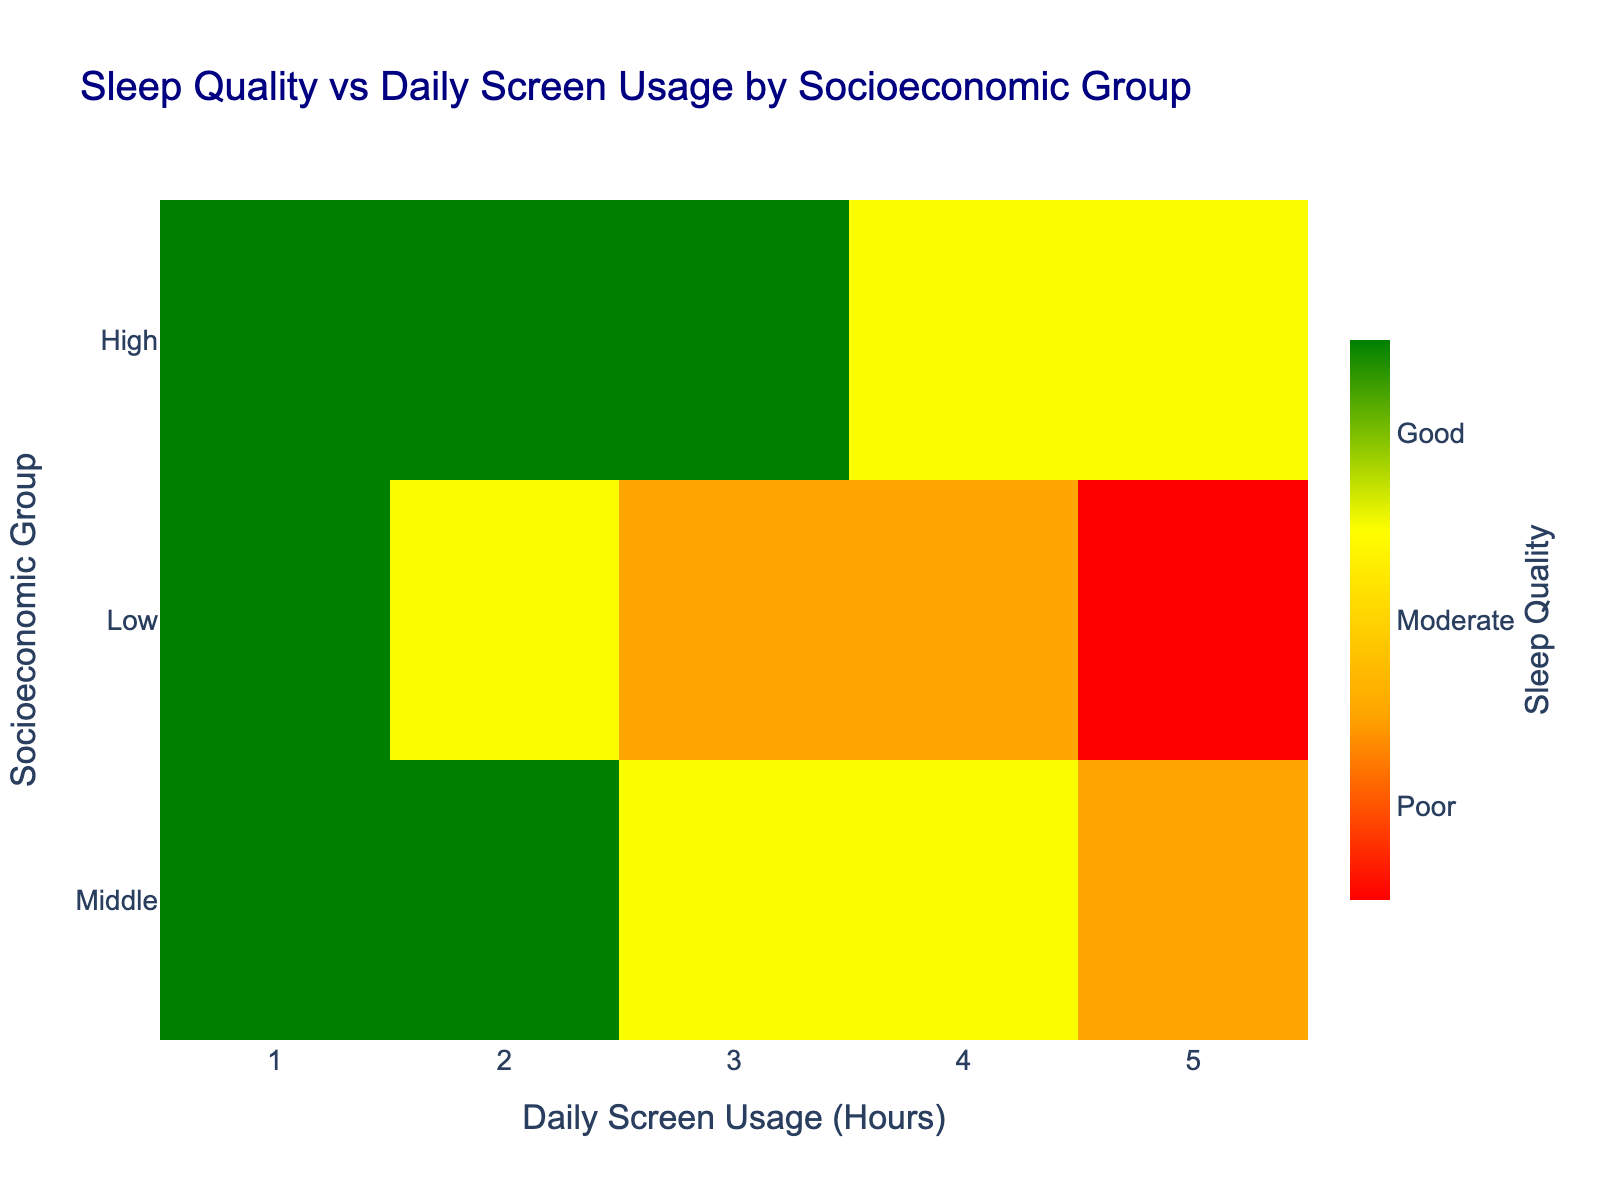What is the title of the heatmap? The title represents the main summary of the heatmap and is usually positioned at the top. It serves to inform the viewer of the subject being visualized.
Answer: Sleep Quality vs Daily Screen Usage by Socioeconomic Group Which socioeconomic group shows the poorest sleep quality with the most screen usage? By looking at the heatmap, identify the row corresponding to the "Poor" and "Very Poor" sleep quality levels and find the column with the highest daily screen usage hours within the "Low" socioeconomic group.
Answer: Low How is sleep quality affected by the increase in daily screen usage hours in the High socioeconomic group? Examine the gradient of colors from the leftmost to rightmost columns in the row corresponding to the High socioeconomic group. As the color changes from green to yellow, it indicates a decline in sleep quality.
Answer: Sleep quality decreases Which socioeconomic group consistently shows good sleep quality with low daily screen usage hours? Look for consistent green shades representing good sleep quality in the lower daily screen usage hours columns across different socioeconomic groups. The High socioeconomic group shows consistent good sleep quality for low screen usage hours (1 and 2 hours).
Answer: High In the Middle socioeconomic group, what is the sleep quality with 4 hours of daily screen usage? Locate the Middle socioeconomic group row and the 4 hours daily screen usage column intersection. The color at this intersection will indicate the sleep quality, which is moderate (color between yellow and orange).
Answer: Moderate How does the sleep quality in the Low socioeconomic group at 3 hours of daily screen usage compare to the Middle socioeconomic group at the same screen usage? Compare the shades/colors at the 3-hour daily screen usage column for both the Low and Middle socioeconomic groups. Middle is Moderate (yellow) whereas Low is Poor (orange).
Answer: Low is Poor and Middle is Moderate What is the pattern observed in sleep quality across all socioeconomic groups with increasing daily screen usage hours? Examine the heatmap columns from left to right for each socioeconomic group. Generally, colors transition from green to red as you move from low to high screen usage hours, indicating that sleep quality worsens with increased daily screen usage.
Answer: Sleep quality worsens Which socioeconomic group exhibits the highest variance in sleep quality with varying daily screen usage hours? Identify the row with the most diverse color range. Middle socioeconomic group shows a clear transition from green to orange, indicating higher variance compared to the consistent transitions in Low and High groups.
Answer: Middle Is there any socioeconomic group that maintains good sleep quality despite higher daily screen usage? Examine the intersections in all rows for high screen usage hours (4-5 hours). No group consistently maintains good sleep quality under high usage, but the High group has moderate sleep quality at higher usage.
Answer: No Based on the heatmap, what daily screen usage duration generally maintains good sleep quality across all socioeconomic groups? By observing where most green shades (indicating good sleep quality) are located along the x-axis hours, most good sleep quality is maintained up to 2 hours of daily screen usage.
Answer: Up to 2 hours 